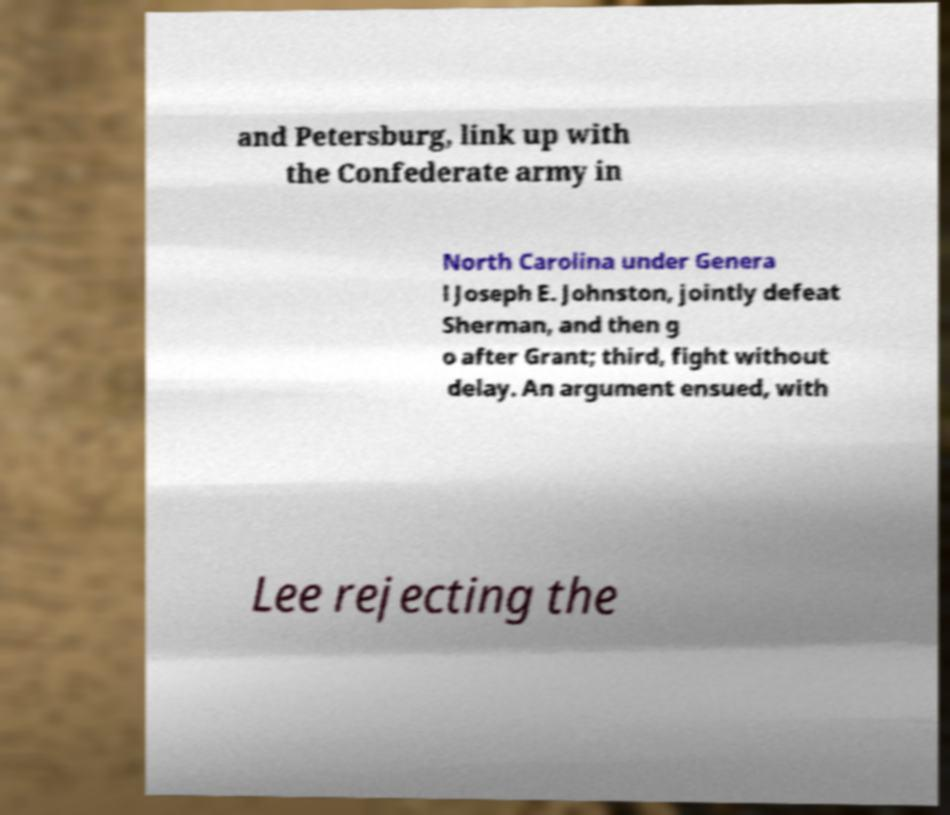Can you accurately transcribe the text from the provided image for me? and Petersburg, link up with the Confederate army in North Carolina under Genera l Joseph E. Johnston, jointly defeat Sherman, and then g o after Grant; third, fight without delay. An argument ensued, with Lee rejecting the 